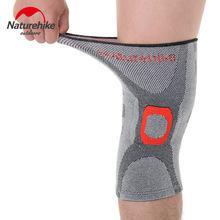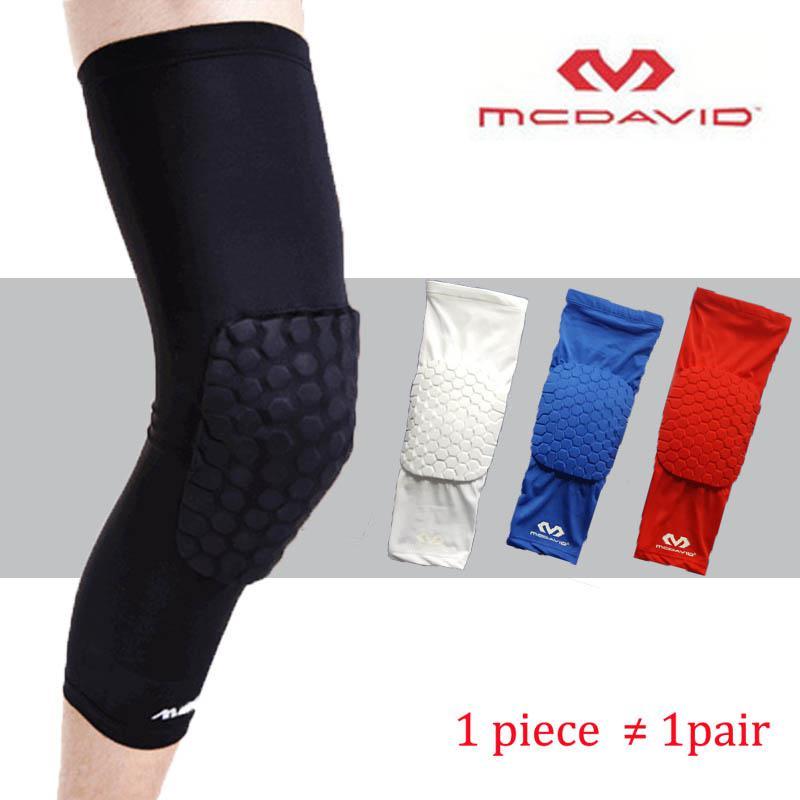The first image is the image on the left, the second image is the image on the right. Examine the images to the left and right. Is the description "Each image shows at least one human leg, and at least one image features a long black compression wrap with a knee pad on its front worn on a leg." accurate? Answer yes or no. Yes. The first image is the image on the left, the second image is the image on the right. For the images displayed, is the sentence "The left and right image contains the same number of medium size knee braces." factually correct? Answer yes or no. No. 